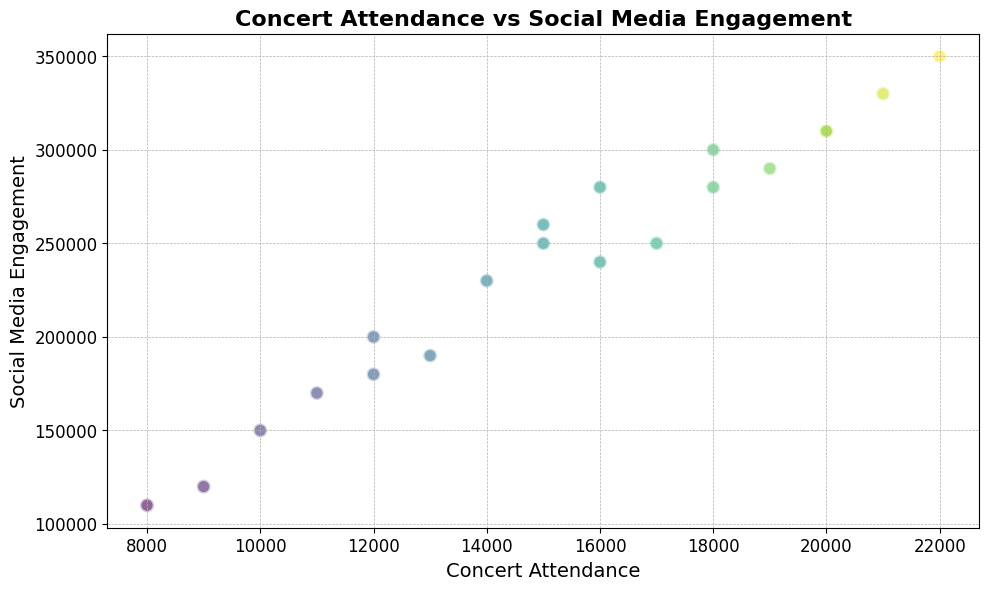what's the average concert attendance? The total concert attendance is calculated by summing all the attendance figures, which is 264000. The number of bands is 20. Therefore, the average concert attendance is 264000 / 20 = 13200.
Answer: 13200 Which band has the highest social media engagement? By looking at the y-axis for the highest point, Band E has the highest social media engagement at 350000.
Answer: Band E Is there a band with both concert attendance and social media engagement below average? The average concert attendance is 13200, and the average social media engagement is 222500. Bands below these averages are Band J with 9000 attendance and 120000 engagement, and Band M with 8000 attendance and 110000 engagement.
Answer: Band J, Band M Which band has a higher concert attendance, Band G or Band P? By looking at the x-axis values, Band P has higher attendance with 20000, compared to Band G with 14000.
Answer: Band P How many bands have social media engagement above 300,000? The bands with social media engagement above 300,000 are Bands C, E, H, K, and P which are 5 bands in total.
Answer: 5 What's the difference in social media engagement between Band B and Band D? Band B has 200000 engagements, and Band D has 150000. The difference is 200000 - 150000 = 50000.
Answer: 50000 Do any bands have equal concert attendance? Bands H and P both have a concert attendance of 20000 as per the x-axis.
Answer: Yes Which band has a similar color in the scatter plot as Band A, indicating similar concert attendance? Band R has a similar color to Band A, indicating analogous concert attendance around 15000.
Answer: Band R What's the total social media engagement for bands with concert attendance of at least 20000? The bands with a concert attendance of at least 20000 are Bands E, H, K, and P with engagements of 350000, 310000, 330000, and 310000 respectively. The total is 350000 + 310000 + 330000 + 310000 = 1300000.
Answer: 1300000 